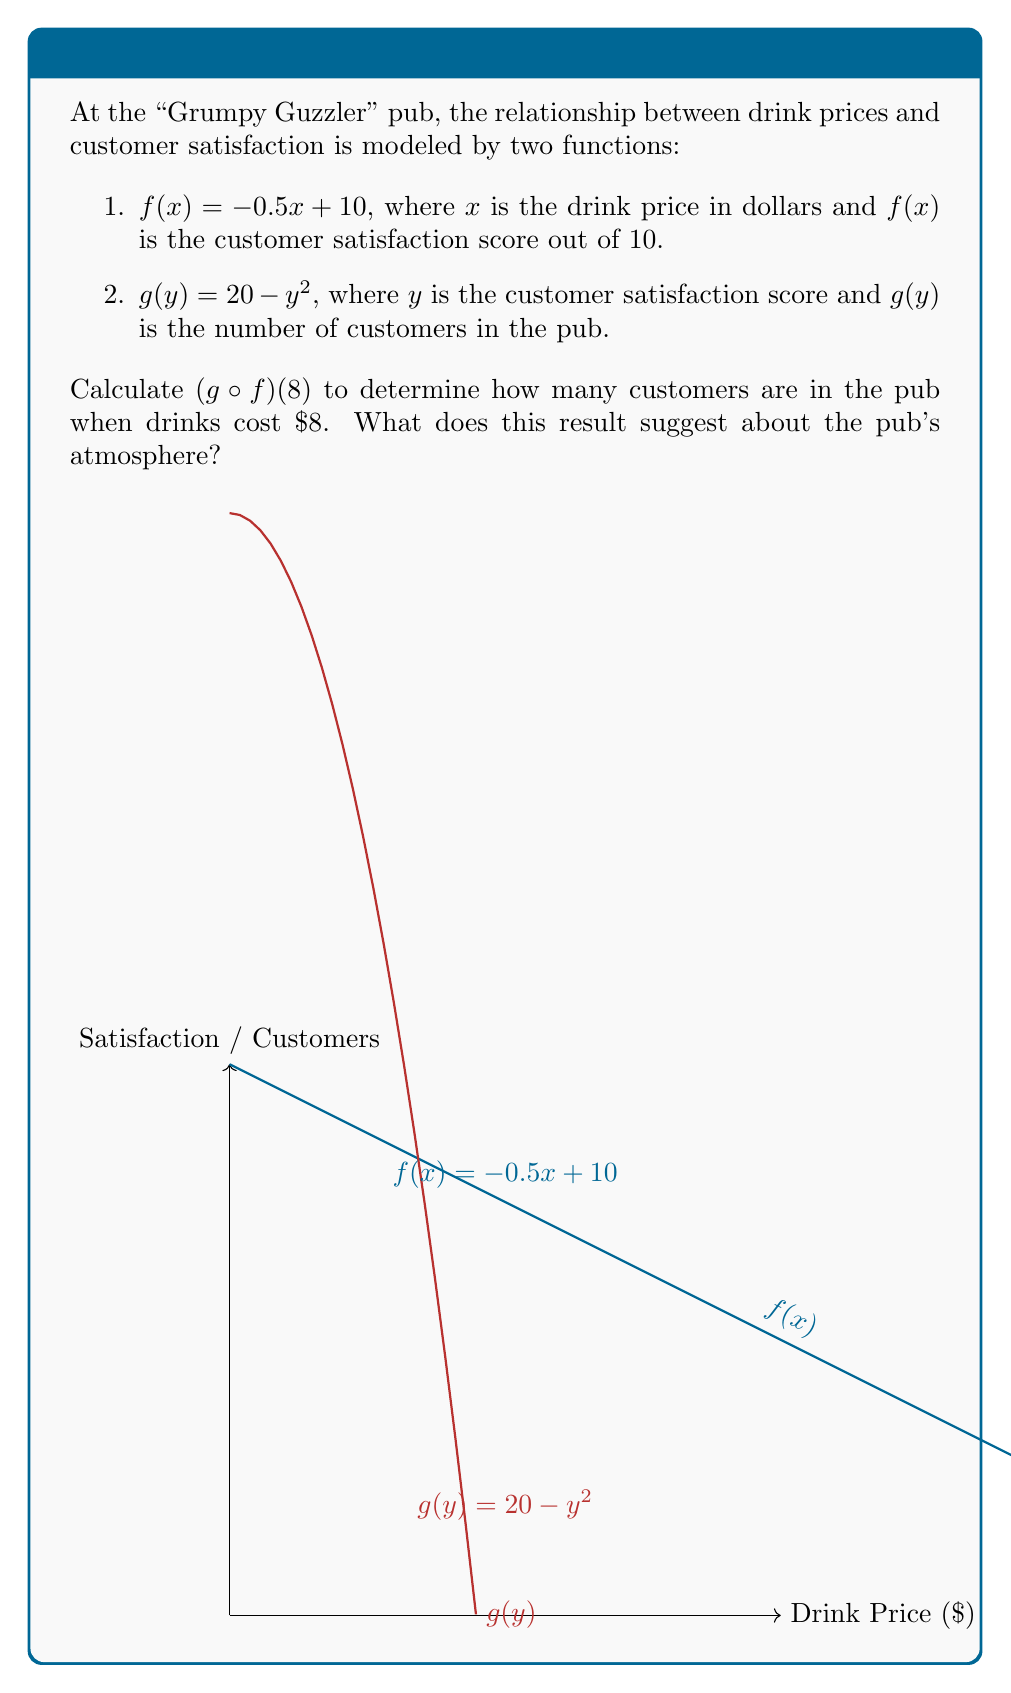Can you solve this math problem? Let's solve this step-by-step:

1) First, we need to find $f(8)$:
   $f(8) = -0.5(8) + 10 = -4 + 10 = 6$

2) Now, we use this result as the input for $g$:
   $g(f(8)) = g(6)$

3) Calculate $g(6)$:
   $g(6) = 20 - 6^2 = 20 - 36 = -16$

4) Therefore, $(g \circ f)(8) = -16$

5) Interpretation: When drinks cost $8, there are -16 customers in the pub. Since we can't have a negative number of customers, this suggests the pub is empty.

This result aligns with the persona of a grouchy pub patron who dislikes crowds. The high drink prices have driven away all customers, creating a quiet, empty atmosphere that our grouchy patron might actually prefer.
Answer: $(g \circ f)(8) = -16$, indicating an empty pub 